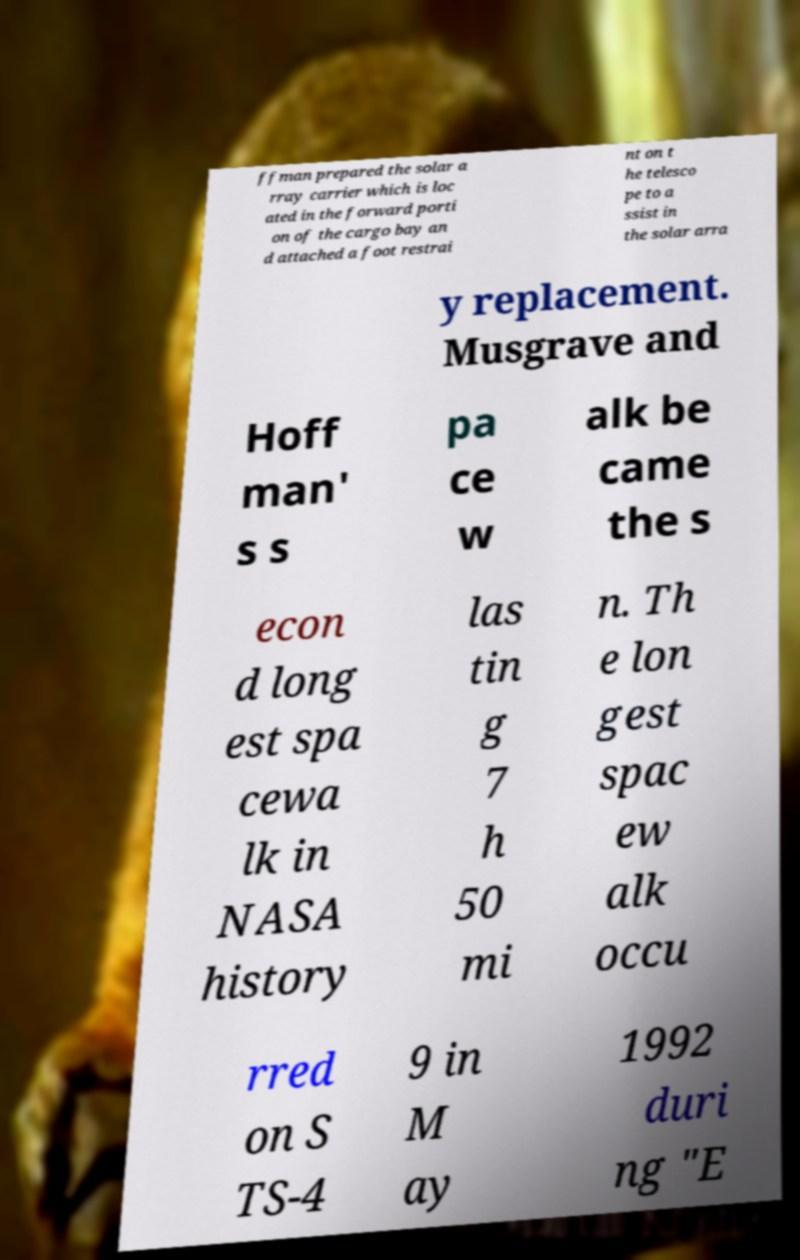Could you assist in decoding the text presented in this image and type it out clearly? ffman prepared the solar a rray carrier which is loc ated in the forward porti on of the cargo bay an d attached a foot restrai nt on t he telesco pe to a ssist in the solar arra y replacement. Musgrave and Hoff man' s s pa ce w alk be came the s econ d long est spa cewa lk in NASA history las tin g 7 h 50 mi n. Th e lon gest spac ew alk occu rred on S TS-4 9 in M ay 1992 duri ng "E 